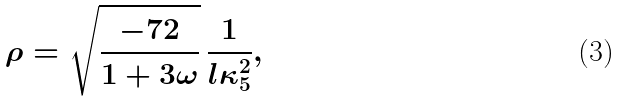Convert formula to latex. <formula><loc_0><loc_0><loc_500><loc_500>\rho = \sqrt { \frac { - 7 2 } { 1 + 3 \omega } } \, \frac { 1 } { l \kappa _ { 5 } ^ { 2 } } ,</formula> 